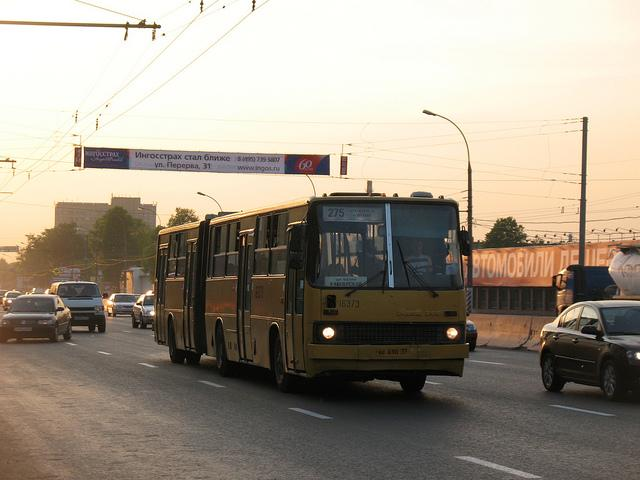What time of day does the bus drive in here? Please explain your reasoning. sunset. The sky is beginning to darken, and the sun is not visible in the sky. all the other listed options take place at a time of day when it would be light outside. 